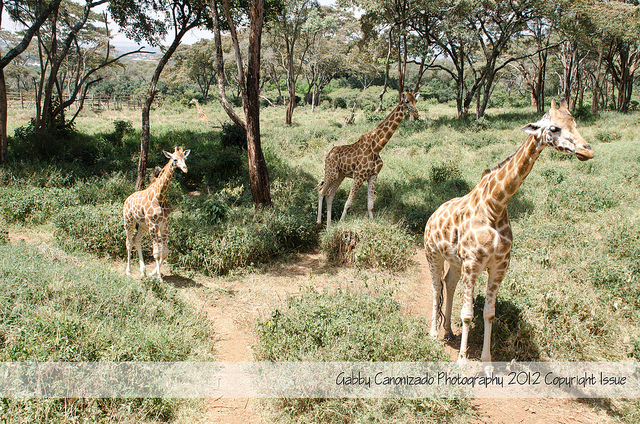Please transcribe the text information in this image. Gabby Canonizado Photograpjy 2012 Copyright Issue 